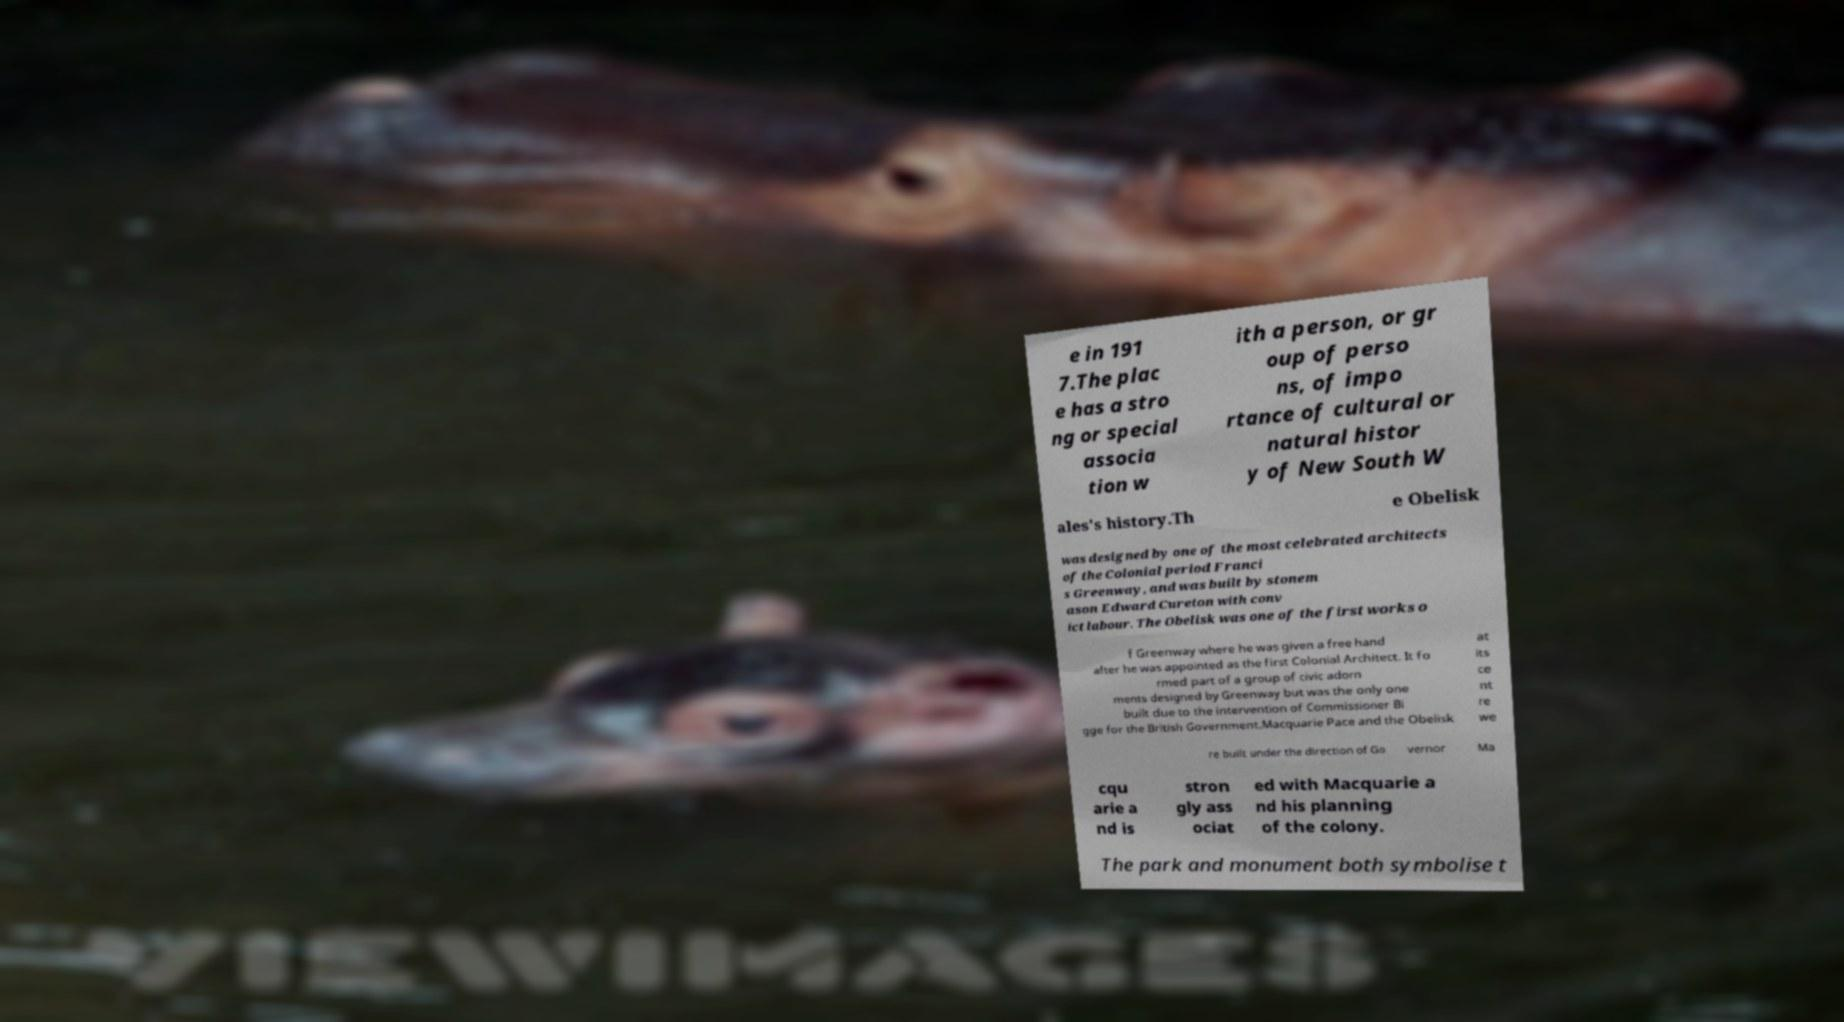Could you assist in decoding the text presented in this image and type it out clearly? e in 191 7.The plac e has a stro ng or special associa tion w ith a person, or gr oup of perso ns, of impo rtance of cultural or natural histor y of New South W ales's history.Th e Obelisk was designed by one of the most celebrated architects of the Colonial period Franci s Greenway, and was built by stonem ason Edward Cureton with conv ict labour. The Obelisk was one of the first works o f Greenway where he was given a free hand after he was appointed as the first Colonial Architect. It fo rmed part of a group of civic adorn ments designed by Greenway but was the only one built due to the intervention of Commissioner Bi gge for the British Government.Macquarie Pace and the Obelisk at its ce nt re we re built under the direction of Go vernor Ma cqu arie a nd is stron gly ass ociat ed with Macquarie a nd his planning of the colony. The park and monument both symbolise t 